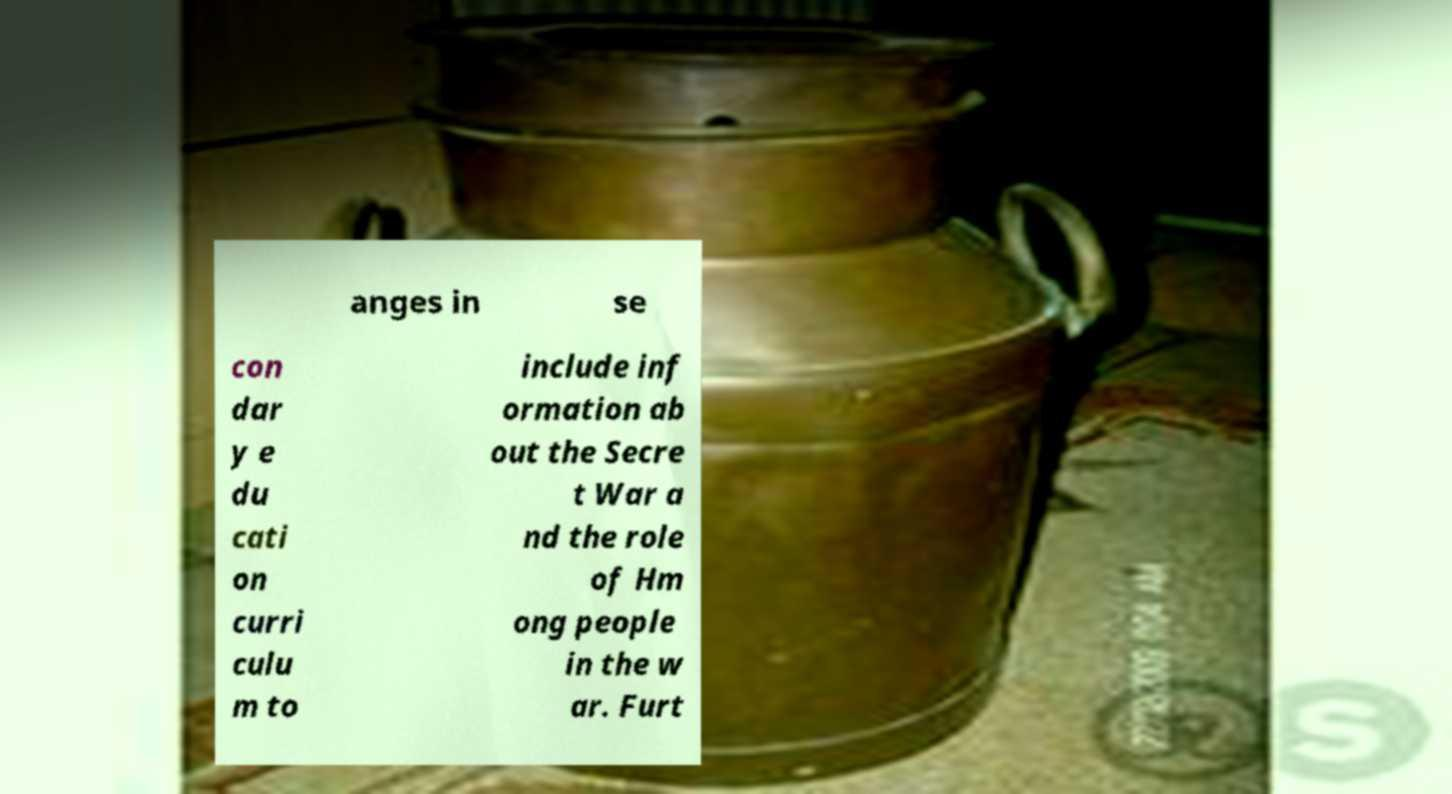Please read and relay the text visible in this image. What does it say? anges in se con dar y e du cati on curri culu m to include inf ormation ab out the Secre t War a nd the role of Hm ong people in the w ar. Furt 